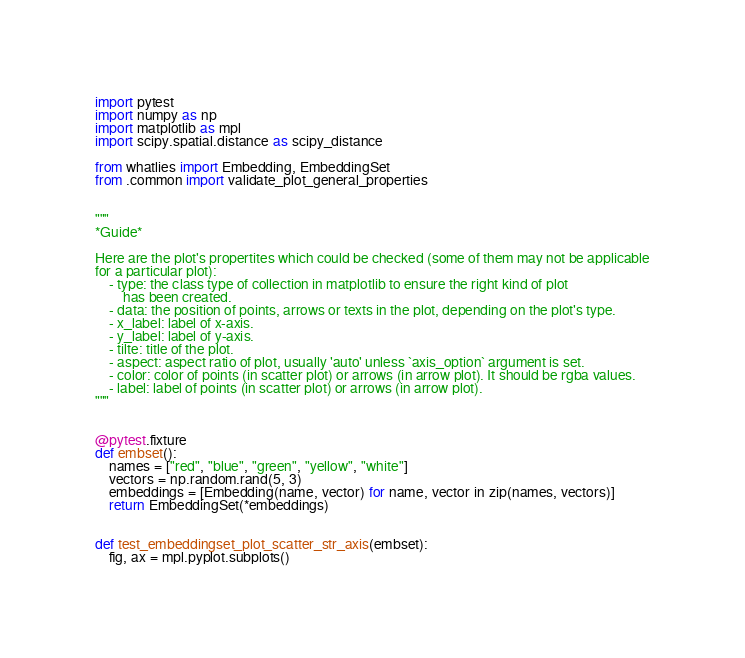<code> <loc_0><loc_0><loc_500><loc_500><_Python_>import pytest
import numpy as np
import matplotlib as mpl
import scipy.spatial.distance as scipy_distance

from whatlies import Embedding, EmbeddingSet
from .common import validate_plot_general_properties


"""
*Guide*

Here are the plot's propertites which could be checked (some of them may not be applicable
for a particular plot):
    - type: the class type of collection in matplotlib to ensure the right kind of plot
        has been created.
    - data: the position of points, arrows or texts in the plot, depending on the plot's type.
    - x_label: label of x-axis.
    - y_label: label of y-axis.
    - tilte: title of the plot.
    - aspect: aspect ratio of plot, usually 'auto' unless `axis_option` argument is set.
    - color: color of points (in scatter plot) or arrows (in arrow plot). It should be rgba values.
    - label: label of points (in scatter plot) or arrows (in arrow plot).
"""


@pytest.fixture
def embset():
    names = ["red", "blue", "green", "yellow", "white"]
    vectors = np.random.rand(5, 3)
    embeddings = [Embedding(name, vector) for name, vector in zip(names, vectors)]
    return EmbeddingSet(*embeddings)


def test_embeddingset_plot_scatter_str_axis(embset):
    fig, ax = mpl.pyplot.subplots()</code> 